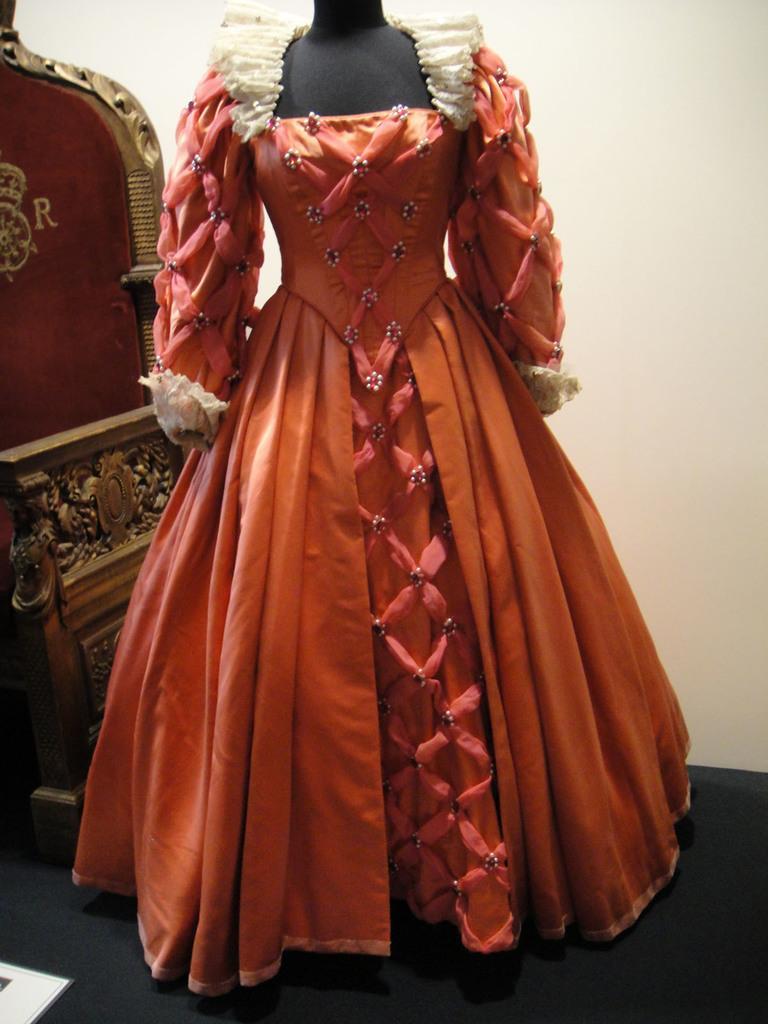Could you give a brief overview of what you see in this image? In this image we can see a dress. To the left side of the image we can see a chair placed on the ground. 